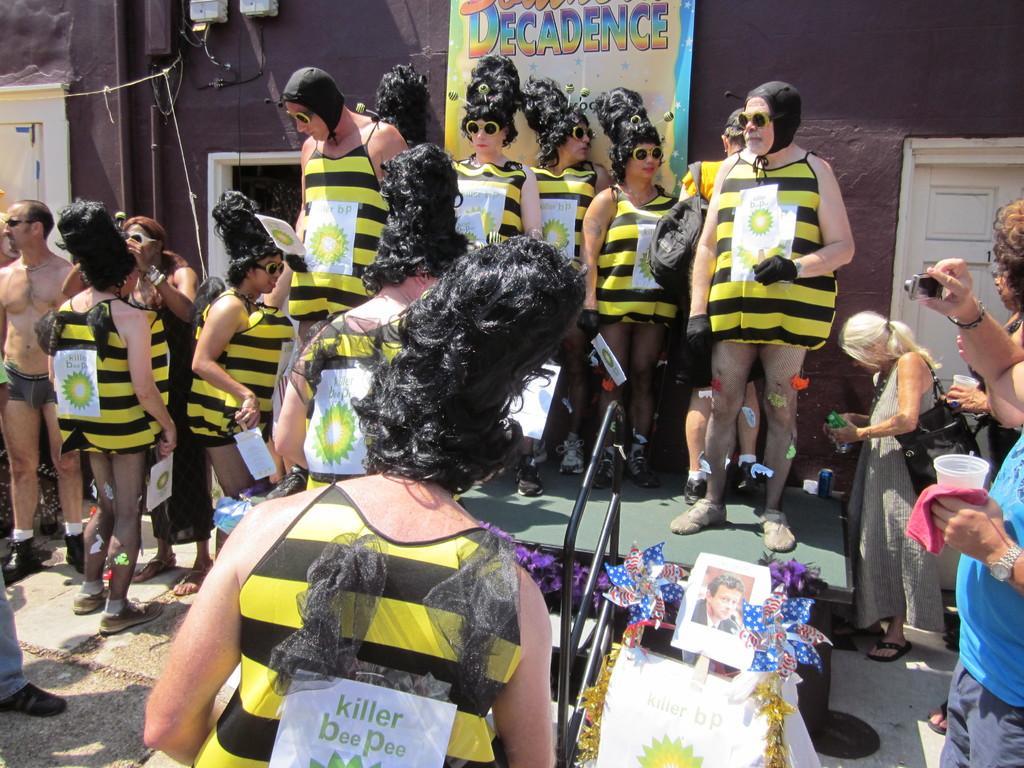Could you give a brief overview of what you see in this image? In this image we can see a few people, among them some people are standing on the stage and holding some objects, there are some flowers, photograph and a staircase in the background we can see the a wall with doors, poster and some other objects. 